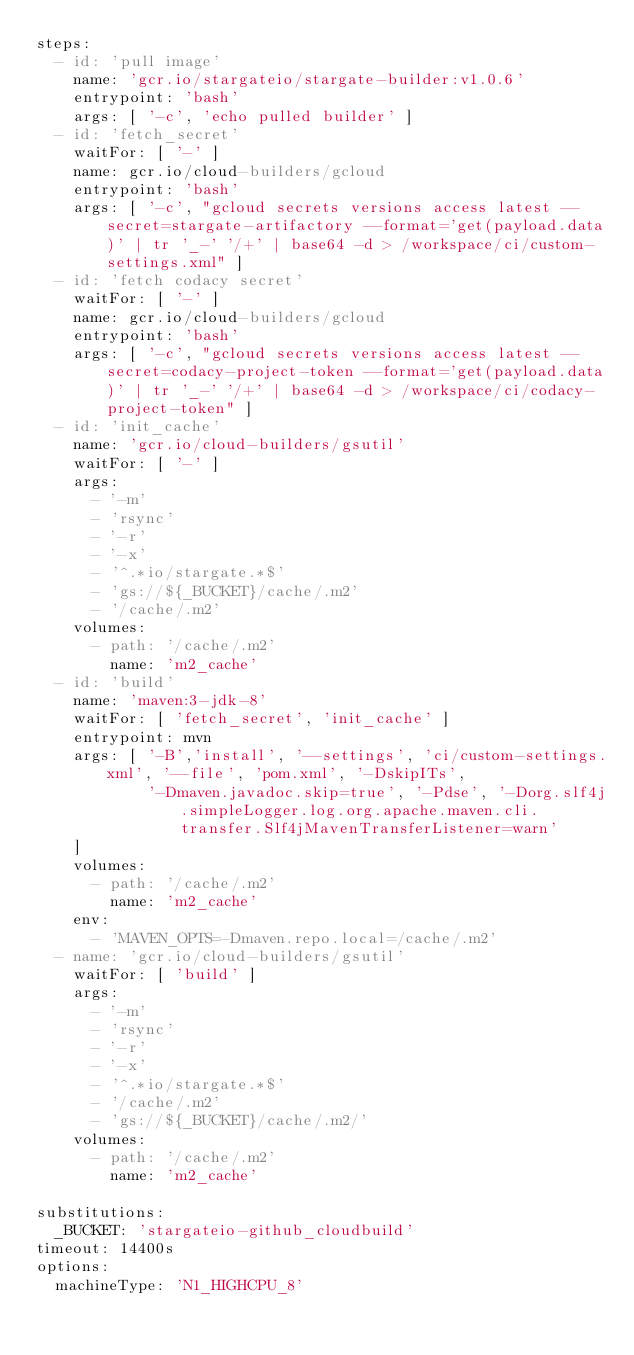<code> <loc_0><loc_0><loc_500><loc_500><_YAML_>steps:
  - id: 'pull image'
    name: 'gcr.io/stargateio/stargate-builder:v1.0.6'
    entrypoint: 'bash'
    args: [ '-c', 'echo pulled builder' ]
  - id: 'fetch_secret'
    waitFor: [ '-' ]
    name: gcr.io/cloud-builders/gcloud
    entrypoint: 'bash'
    args: [ '-c', "gcloud secrets versions access latest --secret=stargate-artifactory --format='get(payload.data)' | tr '_-' '/+' | base64 -d > /workspace/ci/custom-settings.xml" ]
  - id: 'fetch codacy secret'
    waitFor: [ '-' ]
    name: gcr.io/cloud-builders/gcloud
    entrypoint: 'bash'
    args: [ '-c', "gcloud secrets versions access latest --secret=codacy-project-token --format='get(payload.data)' | tr '_-' '/+' | base64 -d > /workspace/ci/codacy-project-token" ]
  - id: 'init_cache'
    name: 'gcr.io/cloud-builders/gsutil'
    waitFor: [ '-' ]
    args:
      - '-m'
      - 'rsync'
      - '-r'
      - '-x'
      - '^.*io/stargate.*$'
      - 'gs://${_BUCKET}/cache/.m2'
      - '/cache/.m2'
    volumes:
      - path: '/cache/.m2'
        name: 'm2_cache'
  - id: 'build'
    name: 'maven:3-jdk-8'
    waitFor: [ 'fetch_secret', 'init_cache' ]
    entrypoint: mvn
    args: [ '-B','install', '--settings', 'ci/custom-settings.xml', '--file', 'pom.xml', '-DskipITs',
            '-Dmaven.javadoc.skip=true', '-Pdse', '-Dorg.slf4j.simpleLogger.log.org.apache.maven.cli.transfer.Slf4jMavenTransferListener=warn'
    ]
    volumes:
      - path: '/cache/.m2'
        name: 'm2_cache'
    env:
      - 'MAVEN_OPTS=-Dmaven.repo.local=/cache/.m2'
  - name: 'gcr.io/cloud-builders/gsutil'
    waitFor: [ 'build' ]
    args:
      - '-m'
      - 'rsync'
      - '-r'
      - '-x'
      - '^.*io/stargate.*$'
      - '/cache/.m2'
      - 'gs://${_BUCKET}/cache/.m2/'
    volumes:
      - path: '/cache/.m2'
        name: 'm2_cache'

substitutions:
  _BUCKET: 'stargateio-github_cloudbuild'
timeout: 14400s
options:
  machineType: 'N1_HIGHCPU_8'
</code> 